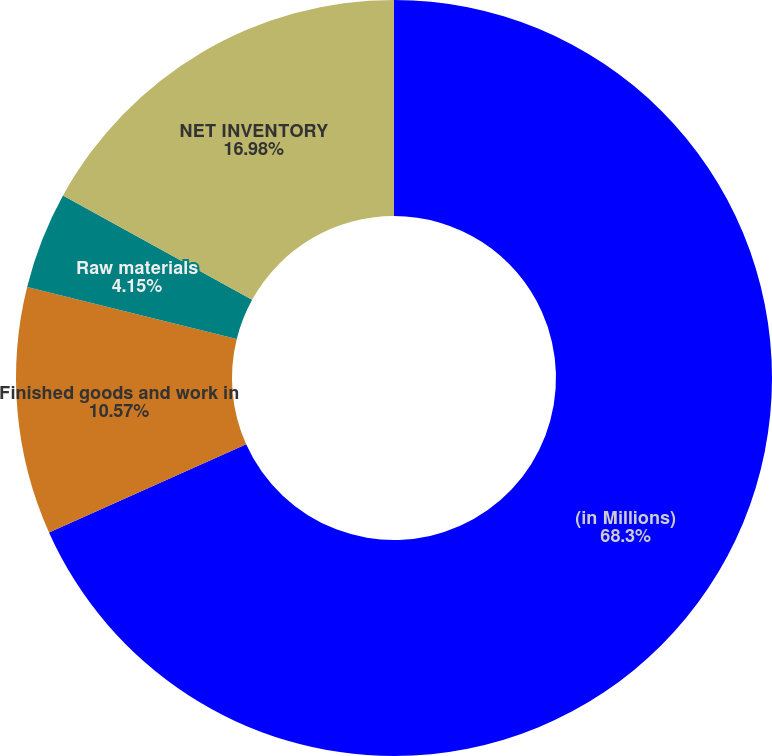<chart> <loc_0><loc_0><loc_500><loc_500><pie_chart><fcel>(in Millions)<fcel>Finished goods and work in<fcel>Raw materials<fcel>NET INVENTORY<nl><fcel>68.3%<fcel>10.57%<fcel>4.15%<fcel>16.98%<nl></chart> 